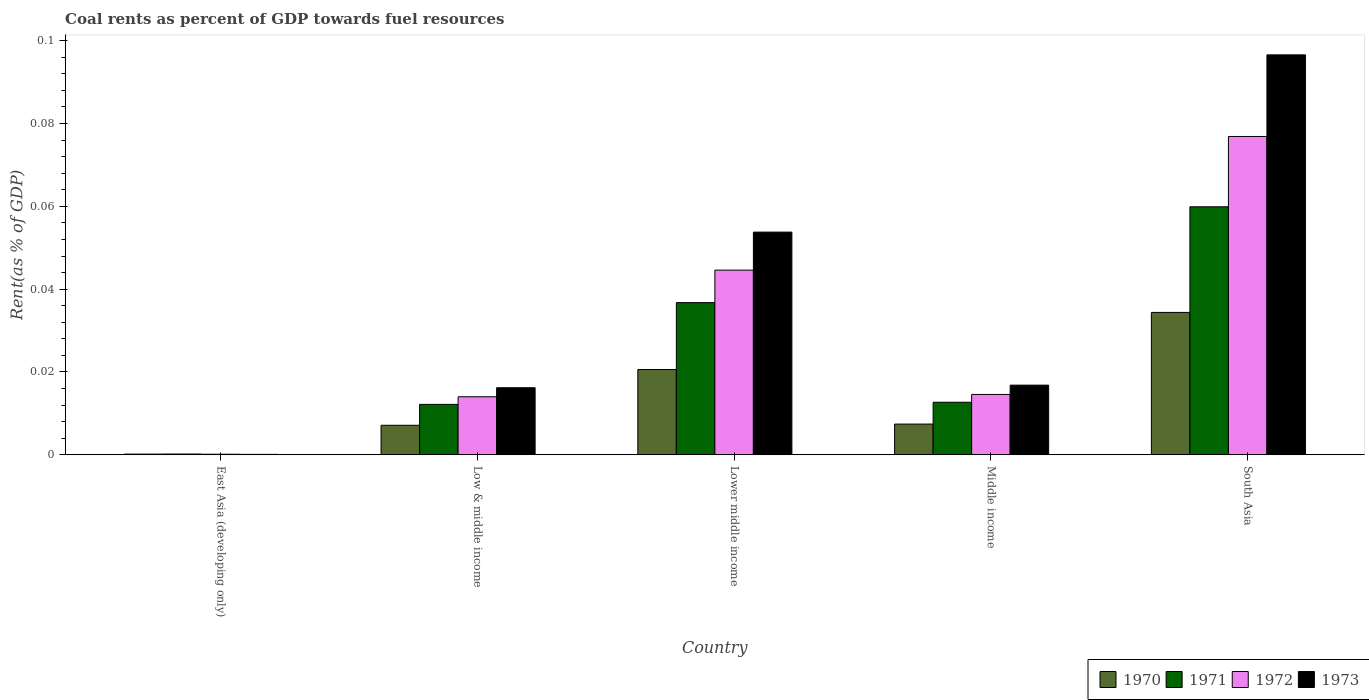How many different coloured bars are there?
Provide a succinct answer. 4. How many groups of bars are there?
Your answer should be very brief. 5. Are the number of bars on each tick of the X-axis equal?
Give a very brief answer. Yes. How many bars are there on the 2nd tick from the left?
Give a very brief answer. 4. How many bars are there on the 3rd tick from the right?
Your answer should be very brief. 4. What is the label of the 1st group of bars from the left?
Provide a succinct answer. East Asia (developing only). What is the coal rent in 1970 in South Asia?
Your response must be concise. 0.03. Across all countries, what is the maximum coal rent in 1971?
Offer a very short reply. 0.06. Across all countries, what is the minimum coal rent in 1972?
Provide a succinct answer. 0. In which country was the coal rent in 1970 minimum?
Your answer should be very brief. East Asia (developing only). What is the total coal rent in 1972 in the graph?
Your answer should be very brief. 0.15. What is the difference between the coal rent in 1973 in Low & middle income and that in South Asia?
Your answer should be compact. -0.08. What is the difference between the coal rent in 1970 in South Asia and the coal rent in 1972 in Lower middle income?
Give a very brief answer. -0.01. What is the average coal rent in 1973 per country?
Your answer should be compact. 0.04. What is the difference between the coal rent of/in 1971 and coal rent of/in 1970 in Lower middle income?
Provide a succinct answer. 0.02. In how many countries, is the coal rent in 1970 greater than 0.056 %?
Provide a short and direct response. 0. What is the ratio of the coal rent in 1973 in Low & middle income to that in Middle income?
Offer a terse response. 0.96. Is the coal rent in 1970 in Low & middle income less than that in Middle income?
Ensure brevity in your answer.  Yes. Is the difference between the coal rent in 1971 in Lower middle income and Middle income greater than the difference between the coal rent in 1970 in Lower middle income and Middle income?
Keep it short and to the point. Yes. What is the difference between the highest and the second highest coal rent in 1970?
Keep it short and to the point. 0.01. What is the difference between the highest and the lowest coal rent in 1970?
Ensure brevity in your answer.  0.03. In how many countries, is the coal rent in 1973 greater than the average coal rent in 1973 taken over all countries?
Your answer should be very brief. 2. Is the sum of the coal rent in 1973 in Lower middle income and Middle income greater than the maximum coal rent in 1971 across all countries?
Your answer should be compact. Yes. Is it the case that in every country, the sum of the coal rent in 1970 and coal rent in 1973 is greater than the sum of coal rent in 1971 and coal rent in 1972?
Your answer should be compact. No. What does the 1st bar from the left in East Asia (developing only) represents?
Provide a succinct answer. 1970. What does the 2nd bar from the right in Middle income represents?
Your answer should be very brief. 1972. Is it the case that in every country, the sum of the coal rent in 1973 and coal rent in 1970 is greater than the coal rent in 1971?
Ensure brevity in your answer.  Yes. How many countries are there in the graph?
Offer a very short reply. 5. What is the difference between two consecutive major ticks on the Y-axis?
Provide a succinct answer. 0.02. Does the graph contain any zero values?
Offer a terse response. No. How many legend labels are there?
Offer a very short reply. 4. What is the title of the graph?
Keep it short and to the point. Coal rents as percent of GDP towards fuel resources. What is the label or title of the X-axis?
Offer a terse response. Country. What is the label or title of the Y-axis?
Your answer should be compact. Rent(as % of GDP). What is the Rent(as % of GDP) in 1970 in East Asia (developing only)?
Your answer should be compact. 0. What is the Rent(as % of GDP) in 1971 in East Asia (developing only)?
Your answer should be compact. 0. What is the Rent(as % of GDP) in 1972 in East Asia (developing only)?
Your answer should be compact. 0. What is the Rent(as % of GDP) of 1973 in East Asia (developing only)?
Your answer should be compact. 0. What is the Rent(as % of GDP) in 1970 in Low & middle income?
Give a very brief answer. 0.01. What is the Rent(as % of GDP) in 1971 in Low & middle income?
Your answer should be compact. 0.01. What is the Rent(as % of GDP) of 1972 in Low & middle income?
Offer a very short reply. 0.01. What is the Rent(as % of GDP) in 1973 in Low & middle income?
Offer a very short reply. 0.02. What is the Rent(as % of GDP) in 1970 in Lower middle income?
Provide a short and direct response. 0.02. What is the Rent(as % of GDP) of 1971 in Lower middle income?
Offer a very short reply. 0.04. What is the Rent(as % of GDP) of 1972 in Lower middle income?
Provide a succinct answer. 0.04. What is the Rent(as % of GDP) of 1973 in Lower middle income?
Provide a succinct answer. 0.05. What is the Rent(as % of GDP) of 1970 in Middle income?
Make the answer very short. 0.01. What is the Rent(as % of GDP) in 1971 in Middle income?
Provide a succinct answer. 0.01. What is the Rent(as % of GDP) in 1972 in Middle income?
Offer a very short reply. 0.01. What is the Rent(as % of GDP) in 1973 in Middle income?
Give a very brief answer. 0.02. What is the Rent(as % of GDP) of 1970 in South Asia?
Your response must be concise. 0.03. What is the Rent(as % of GDP) of 1971 in South Asia?
Your answer should be very brief. 0.06. What is the Rent(as % of GDP) of 1972 in South Asia?
Ensure brevity in your answer.  0.08. What is the Rent(as % of GDP) of 1973 in South Asia?
Provide a short and direct response. 0.1. Across all countries, what is the maximum Rent(as % of GDP) of 1970?
Keep it short and to the point. 0.03. Across all countries, what is the maximum Rent(as % of GDP) of 1971?
Offer a terse response. 0.06. Across all countries, what is the maximum Rent(as % of GDP) of 1972?
Make the answer very short. 0.08. Across all countries, what is the maximum Rent(as % of GDP) in 1973?
Provide a short and direct response. 0.1. Across all countries, what is the minimum Rent(as % of GDP) of 1970?
Your answer should be very brief. 0. Across all countries, what is the minimum Rent(as % of GDP) of 1971?
Give a very brief answer. 0. Across all countries, what is the minimum Rent(as % of GDP) in 1972?
Offer a terse response. 0. Across all countries, what is the minimum Rent(as % of GDP) of 1973?
Offer a very short reply. 0. What is the total Rent(as % of GDP) in 1970 in the graph?
Make the answer very short. 0.07. What is the total Rent(as % of GDP) of 1971 in the graph?
Keep it short and to the point. 0.12. What is the total Rent(as % of GDP) in 1972 in the graph?
Give a very brief answer. 0.15. What is the total Rent(as % of GDP) of 1973 in the graph?
Your response must be concise. 0.18. What is the difference between the Rent(as % of GDP) of 1970 in East Asia (developing only) and that in Low & middle income?
Give a very brief answer. -0.01. What is the difference between the Rent(as % of GDP) in 1971 in East Asia (developing only) and that in Low & middle income?
Your answer should be very brief. -0.01. What is the difference between the Rent(as % of GDP) in 1972 in East Asia (developing only) and that in Low & middle income?
Give a very brief answer. -0.01. What is the difference between the Rent(as % of GDP) of 1973 in East Asia (developing only) and that in Low & middle income?
Your response must be concise. -0.02. What is the difference between the Rent(as % of GDP) in 1970 in East Asia (developing only) and that in Lower middle income?
Ensure brevity in your answer.  -0.02. What is the difference between the Rent(as % of GDP) of 1971 in East Asia (developing only) and that in Lower middle income?
Provide a succinct answer. -0.04. What is the difference between the Rent(as % of GDP) in 1972 in East Asia (developing only) and that in Lower middle income?
Offer a very short reply. -0.04. What is the difference between the Rent(as % of GDP) of 1973 in East Asia (developing only) and that in Lower middle income?
Give a very brief answer. -0.05. What is the difference between the Rent(as % of GDP) in 1970 in East Asia (developing only) and that in Middle income?
Offer a very short reply. -0.01. What is the difference between the Rent(as % of GDP) of 1971 in East Asia (developing only) and that in Middle income?
Give a very brief answer. -0.01. What is the difference between the Rent(as % of GDP) in 1972 in East Asia (developing only) and that in Middle income?
Offer a very short reply. -0.01. What is the difference between the Rent(as % of GDP) of 1973 in East Asia (developing only) and that in Middle income?
Offer a terse response. -0.02. What is the difference between the Rent(as % of GDP) in 1970 in East Asia (developing only) and that in South Asia?
Your answer should be compact. -0.03. What is the difference between the Rent(as % of GDP) in 1971 in East Asia (developing only) and that in South Asia?
Keep it short and to the point. -0.06. What is the difference between the Rent(as % of GDP) in 1972 in East Asia (developing only) and that in South Asia?
Keep it short and to the point. -0.08. What is the difference between the Rent(as % of GDP) of 1973 in East Asia (developing only) and that in South Asia?
Make the answer very short. -0.1. What is the difference between the Rent(as % of GDP) of 1970 in Low & middle income and that in Lower middle income?
Provide a succinct answer. -0.01. What is the difference between the Rent(as % of GDP) of 1971 in Low & middle income and that in Lower middle income?
Offer a terse response. -0.02. What is the difference between the Rent(as % of GDP) of 1972 in Low & middle income and that in Lower middle income?
Offer a terse response. -0.03. What is the difference between the Rent(as % of GDP) in 1973 in Low & middle income and that in Lower middle income?
Offer a terse response. -0.04. What is the difference between the Rent(as % of GDP) of 1970 in Low & middle income and that in Middle income?
Offer a very short reply. -0. What is the difference between the Rent(as % of GDP) in 1971 in Low & middle income and that in Middle income?
Offer a very short reply. -0. What is the difference between the Rent(as % of GDP) in 1972 in Low & middle income and that in Middle income?
Keep it short and to the point. -0. What is the difference between the Rent(as % of GDP) in 1973 in Low & middle income and that in Middle income?
Provide a succinct answer. -0. What is the difference between the Rent(as % of GDP) in 1970 in Low & middle income and that in South Asia?
Offer a terse response. -0.03. What is the difference between the Rent(as % of GDP) in 1971 in Low & middle income and that in South Asia?
Offer a very short reply. -0.05. What is the difference between the Rent(as % of GDP) in 1972 in Low & middle income and that in South Asia?
Your answer should be compact. -0.06. What is the difference between the Rent(as % of GDP) in 1973 in Low & middle income and that in South Asia?
Your response must be concise. -0.08. What is the difference between the Rent(as % of GDP) in 1970 in Lower middle income and that in Middle income?
Give a very brief answer. 0.01. What is the difference between the Rent(as % of GDP) of 1971 in Lower middle income and that in Middle income?
Your answer should be very brief. 0.02. What is the difference between the Rent(as % of GDP) in 1973 in Lower middle income and that in Middle income?
Provide a short and direct response. 0.04. What is the difference between the Rent(as % of GDP) in 1970 in Lower middle income and that in South Asia?
Ensure brevity in your answer.  -0.01. What is the difference between the Rent(as % of GDP) of 1971 in Lower middle income and that in South Asia?
Your answer should be compact. -0.02. What is the difference between the Rent(as % of GDP) in 1972 in Lower middle income and that in South Asia?
Your answer should be compact. -0.03. What is the difference between the Rent(as % of GDP) of 1973 in Lower middle income and that in South Asia?
Give a very brief answer. -0.04. What is the difference between the Rent(as % of GDP) of 1970 in Middle income and that in South Asia?
Your response must be concise. -0.03. What is the difference between the Rent(as % of GDP) in 1971 in Middle income and that in South Asia?
Ensure brevity in your answer.  -0.05. What is the difference between the Rent(as % of GDP) of 1972 in Middle income and that in South Asia?
Make the answer very short. -0.06. What is the difference between the Rent(as % of GDP) in 1973 in Middle income and that in South Asia?
Make the answer very short. -0.08. What is the difference between the Rent(as % of GDP) in 1970 in East Asia (developing only) and the Rent(as % of GDP) in 1971 in Low & middle income?
Your response must be concise. -0.01. What is the difference between the Rent(as % of GDP) of 1970 in East Asia (developing only) and the Rent(as % of GDP) of 1972 in Low & middle income?
Provide a short and direct response. -0.01. What is the difference between the Rent(as % of GDP) of 1970 in East Asia (developing only) and the Rent(as % of GDP) of 1973 in Low & middle income?
Make the answer very short. -0.02. What is the difference between the Rent(as % of GDP) in 1971 in East Asia (developing only) and the Rent(as % of GDP) in 1972 in Low & middle income?
Give a very brief answer. -0.01. What is the difference between the Rent(as % of GDP) of 1971 in East Asia (developing only) and the Rent(as % of GDP) of 1973 in Low & middle income?
Offer a very short reply. -0.02. What is the difference between the Rent(as % of GDP) of 1972 in East Asia (developing only) and the Rent(as % of GDP) of 1973 in Low & middle income?
Make the answer very short. -0.02. What is the difference between the Rent(as % of GDP) in 1970 in East Asia (developing only) and the Rent(as % of GDP) in 1971 in Lower middle income?
Provide a short and direct response. -0.04. What is the difference between the Rent(as % of GDP) in 1970 in East Asia (developing only) and the Rent(as % of GDP) in 1972 in Lower middle income?
Your answer should be very brief. -0.04. What is the difference between the Rent(as % of GDP) in 1970 in East Asia (developing only) and the Rent(as % of GDP) in 1973 in Lower middle income?
Provide a succinct answer. -0.05. What is the difference between the Rent(as % of GDP) of 1971 in East Asia (developing only) and the Rent(as % of GDP) of 1972 in Lower middle income?
Give a very brief answer. -0.04. What is the difference between the Rent(as % of GDP) in 1971 in East Asia (developing only) and the Rent(as % of GDP) in 1973 in Lower middle income?
Your answer should be very brief. -0.05. What is the difference between the Rent(as % of GDP) in 1972 in East Asia (developing only) and the Rent(as % of GDP) in 1973 in Lower middle income?
Ensure brevity in your answer.  -0.05. What is the difference between the Rent(as % of GDP) in 1970 in East Asia (developing only) and the Rent(as % of GDP) in 1971 in Middle income?
Your answer should be very brief. -0.01. What is the difference between the Rent(as % of GDP) of 1970 in East Asia (developing only) and the Rent(as % of GDP) of 1972 in Middle income?
Give a very brief answer. -0.01. What is the difference between the Rent(as % of GDP) in 1970 in East Asia (developing only) and the Rent(as % of GDP) in 1973 in Middle income?
Provide a short and direct response. -0.02. What is the difference between the Rent(as % of GDP) of 1971 in East Asia (developing only) and the Rent(as % of GDP) of 1972 in Middle income?
Provide a succinct answer. -0.01. What is the difference between the Rent(as % of GDP) in 1971 in East Asia (developing only) and the Rent(as % of GDP) in 1973 in Middle income?
Make the answer very short. -0.02. What is the difference between the Rent(as % of GDP) of 1972 in East Asia (developing only) and the Rent(as % of GDP) of 1973 in Middle income?
Ensure brevity in your answer.  -0.02. What is the difference between the Rent(as % of GDP) of 1970 in East Asia (developing only) and the Rent(as % of GDP) of 1971 in South Asia?
Your response must be concise. -0.06. What is the difference between the Rent(as % of GDP) of 1970 in East Asia (developing only) and the Rent(as % of GDP) of 1972 in South Asia?
Your response must be concise. -0.08. What is the difference between the Rent(as % of GDP) in 1970 in East Asia (developing only) and the Rent(as % of GDP) in 1973 in South Asia?
Make the answer very short. -0.1. What is the difference between the Rent(as % of GDP) of 1971 in East Asia (developing only) and the Rent(as % of GDP) of 1972 in South Asia?
Your answer should be compact. -0.08. What is the difference between the Rent(as % of GDP) in 1971 in East Asia (developing only) and the Rent(as % of GDP) in 1973 in South Asia?
Make the answer very short. -0.1. What is the difference between the Rent(as % of GDP) of 1972 in East Asia (developing only) and the Rent(as % of GDP) of 1973 in South Asia?
Provide a succinct answer. -0.1. What is the difference between the Rent(as % of GDP) of 1970 in Low & middle income and the Rent(as % of GDP) of 1971 in Lower middle income?
Make the answer very short. -0.03. What is the difference between the Rent(as % of GDP) in 1970 in Low & middle income and the Rent(as % of GDP) in 1972 in Lower middle income?
Your answer should be compact. -0.04. What is the difference between the Rent(as % of GDP) of 1970 in Low & middle income and the Rent(as % of GDP) of 1973 in Lower middle income?
Provide a succinct answer. -0.05. What is the difference between the Rent(as % of GDP) in 1971 in Low & middle income and the Rent(as % of GDP) in 1972 in Lower middle income?
Your response must be concise. -0.03. What is the difference between the Rent(as % of GDP) of 1971 in Low & middle income and the Rent(as % of GDP) of 1973 in Lower middle income?
Offer a terse response. -0.04. What is the difference between the Rent(as % of GDP) in 1972 in Low & middle income and the Rent(as % of GDP) in 1973 in Lower middle income?
Provide a short and direct response. -0.04. What is the difference between the Rent(as % of GDP) in 1970 in Low & middle income and the Rent(as % of GDP) in 1971 in Middle income?
Give a very brief answer. -0.01. What is the difference between the Rent(as % of GDP) in 1970 in Low & middle income and the Rent(as % of GDP) in 1972 in Middle income?
Provide a succinct answer. -0.01. What is the difference between the Rent(as % of GDP) in 1970 in Low & middle income and the Rent(as % of GDP) in 1973 in Middle income?
Give a very brief answer. -0.01. What is the difference between the Rent(as % of GDP) of 1971 in Low & middle income and the Rent(as % of GDP) of 1972 in Middle income?
Your answer should be very brief. -0. What is the difference between the Rent(as % of GDP) in 1971 in Low & middle income and the Rent(as % of GDP) in 1973 in Middle income?
Offer a very short reply. -0. What is the difference between the Rent(as % of GDP) of 1972 in Low & middle income and the Rent(as % of GDP) of 1973 in Middle income?
Provide a short and direct response. -0. What is the difference between the Rent(as % of GDP) of 1970 in Low & middle income and the Rent(as % of GDP) of 1971 in South Asia?
Give a very brief answer. -0.05. What is the difference between the Rent(as % of GDP) in 1970 in Low & middle income and the Rent(as % of GDP) in 1972 in South Asia?
Offer a terse response. -0.07. What is the difference between the Rent(as % of GDP) in 1970 in Low & middle income and the Rent(as % of GDP) in 1973 in South Asia?
Make the answer very short. -0.09. What is the difference between the Rent(as % of GDP) of 1971 in Low & middle income and the Rent(as % of GDP) of 1972 in South Asia?
Provide a short and direct response. -0.06. What is the difference between the Rent(as % of GDP) in 1971 in Low & middle income and the Rent(as % of GDP) in 1973 in South Asia?
Offer a terse response. -0.08. What is the difference between the Rent(as % of GDP) of 1972 in Low & middle income and the Rent(as % of GDP) of 1973 in South Asia?
Your answer should be very brief. -0.08. What is the difference between the Rent(as % of GDP) in 1970 in Lower middle income and the Rent(as % of GDP) in 1971 in Middle income?
Provide a succinct answer. 0.01. What is the difference between the Rent(as % of GDP) in 1970 in Lower middle income and the Rent(as % of GDP) in 1972 in Middle income?
Provide a short and direct response. 0.01. What is the difference between the Rent(as % of GDP) of 1970 in Lower middle income and the Rent(as % of GDP) of 1973 in Middle income?
Your answer should be compact. 0. What is the difference between the Rent(as % of GDP) in 1971 in Lower middle income and the Rent(as % of GDP) in 1972 in Middle income?
Offer a very short reply. 0.02. What is the difference between the Rent(as % of GDP) of 1971 in Lower middle income and the Rent(as % of GDP) of 1973 in Middle income?
Make the answer very short. 0.02. What is the difference between the Rent(as % of GDP) of 1972 in Lower middle income and the Rent(as % of GDP) of 1973 in Middle income?
Make the answer very short. 0.03. What is the difference between the Rent(as % of GDP) of 1970 in Lower middle income and the Rent(as % of GDP) of 1971 in South Asia?
Your response must be concise. -0.04. What is the difference between the Rent(as % of GDP) of 1970 in Lower middle income and the Rent(as % of GDP) of 1972 in South Asia?
Your answer should be very brief. -0.06. What is the difference between the Rent(as % of GDP) in 1970 in Lower middle income and the Rent(as % of GDP) in 1973 in South Asia?
Make the answer very short. -0.08. What is the difference between the Rent(as % of GDP) in 1971 in Lower middle income and the Rent(as % of GDP) in 1972 in South Asia?
Make the answer very short. -0.04. What is the difference between the Rent(as % of GDP) of 1971 in Lower middle income and the Rent(as % of GDP) of 1973 in South Asia?
Offer a very short reply. -0.06. What is the difference between the Rent(as % of GDP) of 1972 in Lower middle income and the Rent(as % of GDP) of 1973 in South Asia?
Offer a terse response. -0.05. What is the difference between the Rent(as % of GDP) of 1970 in Middle income and the Rent(as % of GDP) of 1971 in South Asia?
Provide a short and direct response. -0.05. What is the difference between the Rent(as % of GDP) of 1970 in Middle income and the Rent(as % of GDP) of 1972 in South Asia?
Give a very brief answer. -0.07. What is the difference between the Rent(as % of GDP) in 1970 in Middle income and the Rent(as % of GDP) in 1973 in South Asia?
Your response must be concise. -0.09. What is the difference between the Rent(as % of GDP) in 1971 in Middle income and the Rent(as % of GDP) in 1972 in South Asia?
Ensure brevity in your answer.  -0.06. What is the difference between the Rent(as % of GDP) of 1971 in Middle income and the Rent(as % of GDP) of 1973 in South Asia?
Give a very brief answer. -0.08. What is the difference between the Rent(as % of GDP) in 1972 in Middle income and the Rent(as % of GDP) in 1973 in South Asia?
Provide a succinct answer. -0.08. What is the average Rent(as % of GDP) in 1970 per country?
Make the answer very short. 0.01. What is the average Rent(as % of GDP) of 1971 per country?
Give a very brief answer. 0.02. What is the average Rent(as % of GDP) in 1972 per country?
Offer a very short reply. 0.03. What is the average Rent(as % of GDP) of 1973 per country?
Keep it short and to the point. 0.04. What is the difference between the Rent(as % of GDP) in 1970 and Rent(as % of GDP) in 1973 in East Asia (developing only)?
Ensure brevity in your answer.  0. What is the difference between the Rent(as % of GDP) in 1971 and Rent(as % of GDP) in 1972 in East Asia (developing only)?
Your answer should be compact. 0. What is the difference between the Rent(as % of GDP) in 1971 and Rent(as % of GDP) in 1973 in East Asia (developing only)?
Make the answer very short. 0. What is the difference between the Rent(as % of GDP) of 1970 and Rent(as % of GDP) of 1971 in Low & middle income?
Ensure brevity in your answer.  -0.01. What is the difference between the Rent(as % of GDP) in 1970 and Rent(as % of GDP) in 1972 in Low & middle income?
Your answer should be very brief. -0.01. What is the difference between the Rent(as % of GDP) in 1970 and Rent(as % of GDP) in 1973 in Low & middle income?
Give a very brief answer. -0.01. What is the difference between the Rent(as % of GDP) in 1971 and Rent(as % of GDP) in 1972 in Low & middle income?
Offer a terse response. -0. What is the difference between the Rent(as % of GDP) of 1971 and Rent(as % of GDP) of 1973 in Low & middle income?
Give a very brief answer. -0. What is the difference between the Rent(as % of GDP) of 1972 and Rent(as % of GDP) of 1973 in Low & middle income?
Ensure brevity in your answer.  -0. What is the difference between the Rent(as % of GDP) of 1970 and Rent(as % of GDP) of 1971 in Lower middle income?
Provide a short and direct response. -0.02. What is the difference between the Rent(as % of GDP) in 1970 and Rent(as % of GDP) in 1972 in Lower middle income?
Ensure brevity in your answer.  -0.02. What is the difference between the Rent(as % of GDP) in 1970 and Rent(as % of GDP) in 1973 in Lower middle income?
Offer a very short reply. -0.03. What is the difference between the Rent(as % of GDP) of 1971 and Rent(as % of GDP) of 1972 in Lower middle income?
Offer a terse response. -0.01. What is the difference between the Rent(as % of GDP) in 1971 and Rent(as % of GDP) in 1973 in Lower middle income?
Provide a short and direct response. -0.02. What is the difference between the Rent(as % of GDP) in 1972 and Rent(as % of GDP) in 1973 in Lower middle income?
Offer a very short reply. -0.01. What is the difference between the Rent(as % of GDP) of 1970 and Rent(as % of GDP) of 1971 in Middle income?
Your response must be concise. -0.01. What is the difference between the Rent(as % of GDP) in 1970 and Rent(as % of GDP) in 1972 in Middle income?
Provide a succinct answer. -0.01. What is the difference between the Rent(as % of GDP) in 1970 and Rent(as % of GDP) in 1973 in Middle income?
Ensure brevity in your answer.  -0.01. What is the difference between the Rent(as % of GDP) of 1971 and Rent(as % of GDP) of 1972 in Middle income?
Provide a short and direct response. -0. What is the difference between the Rent(as % of GDP) of 1971 and Rent(as % of GDP) of 1973 in Middle income?
Provide a succinct answer. -0. What is the difference between the Rent(as % of GDP) in 1972 and Rent(as % of GDP) in 1973 in Middle income?
Offer a terse response. -0. What is the difference between the Rent(as % of GDP) in 1970 and Rent(as % of GDP) in 1971 in South Asia?
Keep it short and to the point. -0.03. What is the difference between the Rent(as % of GDP) of 1970 and Rent(as % of GDP) of 1972 in South Asia?
Your response must be concise. -0.04. What is the difference between the Rent(as % of GDP) of 1970 and Rent(as % of GDP) of 1973 in South Asia?
Make the answer very short. -0.06. What is the difference between the Rent(as % of GDP) of 1971 and Rent(as % of GDP) of 1972 in South Asia?
Your response must be concise. -0.02. What is the difference between the Rent(as % of GDP) in 1971 and Rent(as % of GDP) in 1973 in South Asia?
Offer a very short reply. -0.04. What is the difference between the Rent(as % of GDP) of 1972 and Rent(as % of GDP) of 1973 in South Asia?
Ensure brevity in your answer.  -0.02. What is the ratio of the Rent(as % of GDP) in 1970 in East Asia (developing only) to that in Low & middle income?
Provide a succinct answer. 0.02. What is the ratio of the Rent(as % of GDP) in 1971 in East Asia (developing only) to that in Low & middle income?
Ensure brevity in your answer.  0.02. What is the ratio of the Rent(as % of GDP) in 1972 in East Asia (developing only) to that in Low & middle income?
Ensure brevity in your answer.  0.01. What is the ratio of the Rent(as % of GDP) in 1973 in East Asia (developing only) to that in Low & middle income?
Make the answer very short. 0.01. What is the ratio of the Rent(as % of GDP) of 1970 in East Asia (developing only) to that in Lower middle income?
Ensure brevity in your answer.  0.01. What is the ratio of the Rent(as % of GDP) in 1971 in East Asia (developing only) to that in Lower middle income?
Offer a terse response. 0.01. What is the ratio of the Rent(as % of GDP) of 1972 in East Asia (developing only) to that in Lower middle income?
Make the answer very short. 0. What is the ratio of the Rent(as % of GDP) of 1973 in East Asia (developing only) to that in Lower middle income?
Make the answer very short. 0. What is the ratio of the Rent(as % of GDP) in 1970 in East Asia (developing only) to that in Middle income?
Provide a succinct answer. 0.02. What is the ratio of the Rent(as % of GDP) in 1971 in East Asia (developing only) to that in Middle income?
Give a very brief answer. 0.01. What is the ratio of the Rent(as % of GDP) of 1972 in East Asia (developing only) to that in Middle income?
Make the answer very short. 0.01. What is the ratio of the Rent(as % of GDP) of 1973 in East Asia (developing only) to that in Middle income?
Provide a short and direct response. 0.01. What is the ratio of the Rent(as % of GDP) in 1970 in East Asia (developing only) to that in South Asia?
Give a very brief answer. 0. What is the ratio of the Rent(as % of GDP) in 1971 in East Asia (developing only) to that in South Asia?
Make the answer very short. 0. What is the ratio of the Rent(as % of GDP) in 1972 in East Asia (developing only) to that in South Asia?
Your answer should be compact. 0. What is the ratio of the Rent(as % of GDP) of 1973 in East Asia (developing only) to that in South Asia?
Give a very brief answer. 0. What is the ratio of the Rent(as % of GDP) of 1970 in Low & middle income to that in Lower middle income?
Keep it short and to the point. 0.35. What is the ratio of the Rent(as % of GDP) of 1971 in Low & middle income to that in Lower middle income?
Keep it short and to the point. 0.33. What is the ratio of the Rent(as % of GDP) of 1972 in Low & middle income to that in Lower middle income?
Your answer should be very brief. 0.31. What is the ratio of the Rent(as % of GDP) in 1973 in Low & middle income to that in Lower middle income?
Provide a succinct answer. 0.3. What is the ratio of the Rent(as % of GDP) in 1970 in Low & middle income to that in Middle income?
Your response must be concise. 0.96. What is the ratio of the Rent(as % of GDP) of 1971 in Low & middle income to that in Middle income?
Ensure brevity in your answer.  0.96. What is the ratio of the Rent(as % of GDP) in 1972 in Low & middle income to that in Middle income?
Offer a terse response. 0.96. What is the ratio of the Rent(as % of GDP) in 1973 in Low & middle income to that in Middle income?
Offer a terse response. 0.96. What is the ratio of the Rent(as % of GDP) of 1970 in Low & middle income to that in South Asia?
Provide a succinct answer. 0.21. What is the ratio of the Rent(as % of GDP) in 1971 in Low & middle income to that in South Asia?
Offer a very short reply. 0.2. What is the ratio of the Rent(as % of GDP) in 1972 in Low & middle income to that in South Asia?
Give a very brief answer. 0.18. What is the ratio of the Rent(as % of GDP) of 1973 in Low & middle income to that in South Asia?
Give a very brief answer. 0.17. What is the ratio of the Rent(as % of GDP) of 1970 in Lower middle income to that in Middle income?
Your answer should be very brief. 2.78. What is the ratio of the Rent(as % of GDP) of 1971 in Lower middle income to that in Middle income?
Your answer should be very brief. 2.9. What is the ratio of the Rent(as % of GDP) of 1972 in Lower middle income to that in Middle income?
Your answer should be compact. 3.06. What is the ratio of the Rent(as % of GDP) of 1973 in Lower middle income to that in Middle income?
Your answer should be compact. 3.2. What is the ratio of the Rent(as % of GDP) in 1970 in Lower middle income to that in South Asia?
Provide a short and direct response. 0.6. What is the ratio of the Rent(as % of GDP) of 1971 in Lower middle income to that in South Asia?
Make the answer very short. 0.61. What is the ratio of the Rent(as % of GDP) in 1972 in Lower middle income to that in South Asia?
Your response must be concise. 0.58. What is the ratio of the Rent(as % of GDP) of 1973 in Lower middle income to that in South Asia?
Your answer should be very brief. 0.56. What is the ratio of the Rent(as % of GDP) of 1970 in Middle income to that in South Asia?
Ensure brevity in your answer.  0.22. What is the ratio of the Rent(as % of GDP) of 1971 in Middle income to that in South Asia?
Offer a terse response. 0.21. What is the ratio of the Rent(as % of GDP) of 1972 in Middle income to that in South Asia?
Provide a short and direct response. 0.19. What is the ratio of the Rent(as % of GDP) in 1973 in Middle income to that in South Asia?
Make the answer very short. 0.17. What is the difference between the highest and the second highest Rent(as % of GDP) of 1970?
Offer a very short reply. 0.01. What is the difference between the highest and the second highest Rent(as % of GDP) of 1971?
Your answer should be very brief. 0.02. What is the difference between the highest and the second highest Rent(as % of GDP) of 1972?
Your response must be concise. 0.03. What is the difference between the highest and the second highest Rent(as % of GDP) of 1973?
Offer a very short reply. 0.04. What is the difference between the highest and the lowest Rent(as % of GDP) of 1970?
Give a very brief answer. 0.03. What is the difference between the highest and the lowest Rent(as % of GDP) of 1971?
Provide a short and direct response. 0.06. What is the difference between the highest and the lowest Rent(as % of GDP) in 1972?
Give a very brief answer. 0.08. What is the difference between the highest and the lowest Rent(as % of GDP) of 1973?
Offer a very short reply. 0.1. 